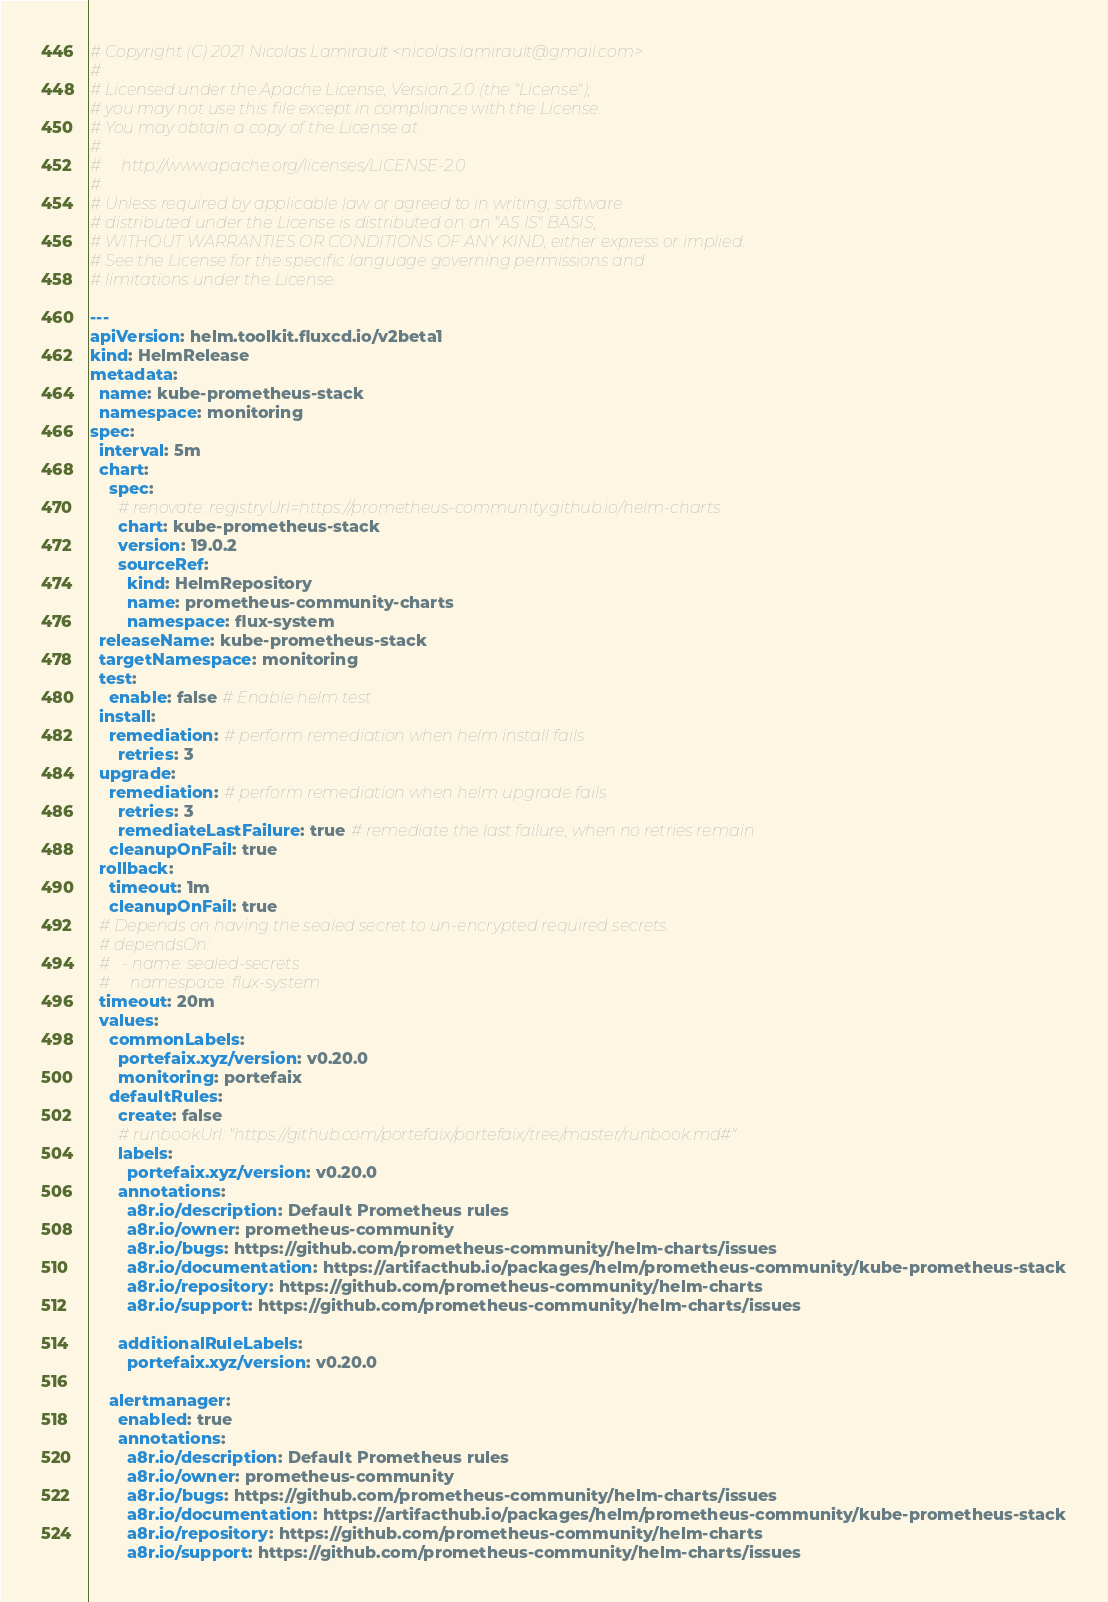Convert code to text. <code><loc_0><loc_0><loc_500><loc_500><_YAML_># Copyright (C) 2021 Nicolas Lamirault <nicolas.lamirault@gmail.com>
#
# Licensed under the Apache License, Version 2.0 (the "License");
# you may not use this file except in compliance with the License.
# You may obtain a copy of the License at
#
#     http://www.apache.org/licenses/LICENSE-2.0
#
# Unless required by applicable law or agreed to in writing, software
# distributed under the License is distributed on an "AS IS" BASIS,
# WITHOUT WARRANTIES OR CONDITIONS OF ANY KIND, either express or implied.
# See the License for the specific language governing permissions and
# limitations under the License.

---
apiVersion: helm.toolkit.fluxcd.io/v2beta1
kind: HelmRelease
metadata:
  name: kube-prometheus-stack
  namespace: monitoring
spec:
  interval: 5m
  chart:
    spec:
      # renovate: registryUrl=https://prometheus-community.github.io/helm-charts
      chart: kube-prometheus-stack
      version: 19.0.2
      sourceRef:
        kind: HelmRepository
        name: prometheus-community-charts
        namespace: flux-system
  releaseName: kube-prometheus-stack
  targetNamespace: monitoring
  test:
    enable: false # Enable helm test
  install:
    remediation: # perform remediation when helm install fails
      retries: 3
  upgrade:
    remediation: # perform remediation when helm upgrade fails
      retries: 3
      remediateLastFailure: true # remediate the last failure, when no retries remain
    cleanupOnFail: true
  rollback:
    timeout: 1m
    cleanupOnFail: true
  # Depends on having the sealed secret to un-encrypted required secrets.
  # dependsOn:
  #   - name: sealed-secrets
  #     namespace: flux-system
  timeout: 20m
  values:
    commonLabels:
      portefaix.xyz/version: v0.20.0
      monitoring: portefaix
    defaultRules:
      create: false
      # runbookUrl: "https://github.com/portefaix/portefaix/tree/master/runbook.md#"
      labels:
        portefaix.xyz/version: v0.20.0
      annotations:
        a8r.io/description: Default Prometheus rules
        a8r.io/owner: prometheus-community
        a8r.io/bugs: https://github.com/prometheus-community/helm-charts/issues
        a8r.io/documentation: https://artifacthub.io/packages/helm/prometheus-community/kube-prometheus-stack
        a8r.io/repository: https://github.com/prometheus-community/helm-charts
        a8r.io/support: https://github.com/prometheus-community/helm-charts/issues

      additionalRuleLabels:
        portefaix.xyz/version: v0.20.0

    alertmanager:
      enabled: true
      annotations:
        a8r.io/description: Default Prometheus rules
        a8r.io/owner: prometheus-community
        a8r.io/bugs: https://github.com/prometheus-community/helm-charts/issues
        a8r.io/documentation: https://artifacthub.io/packages/helm/prometheus-community/kube-prometheus-stack
        a8r.io/repository: https://github.com/prometheus-community/helm-charts
        a8r.io/support: https://github.com/prometheus-community/helm-charts/issues</code> 